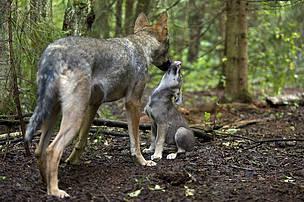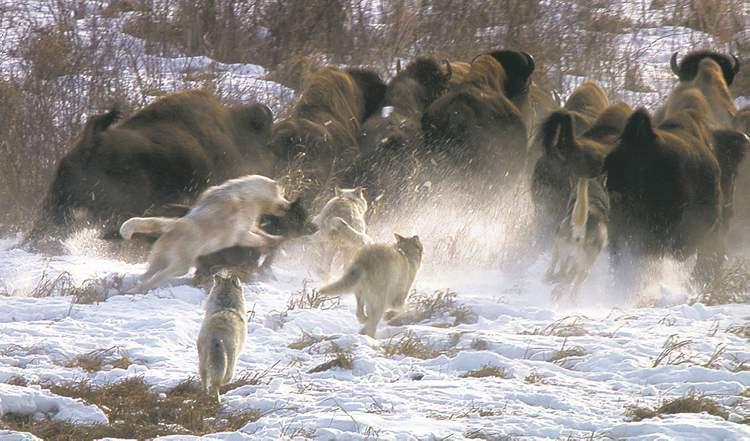The first image is the image on the left, the second image is the image on the right. Assess this claim about the two images: "A herd of buffalo are behind multiple wolves on snow-covered ground in the right image.". Correct or not? Answer yes or no. Yes. The first image is the image on the left, the second image is the image on the right. Analyze the images presented: Is the assertion "The right image contains exactly one wolf." valid? Answer yes or no. No. 